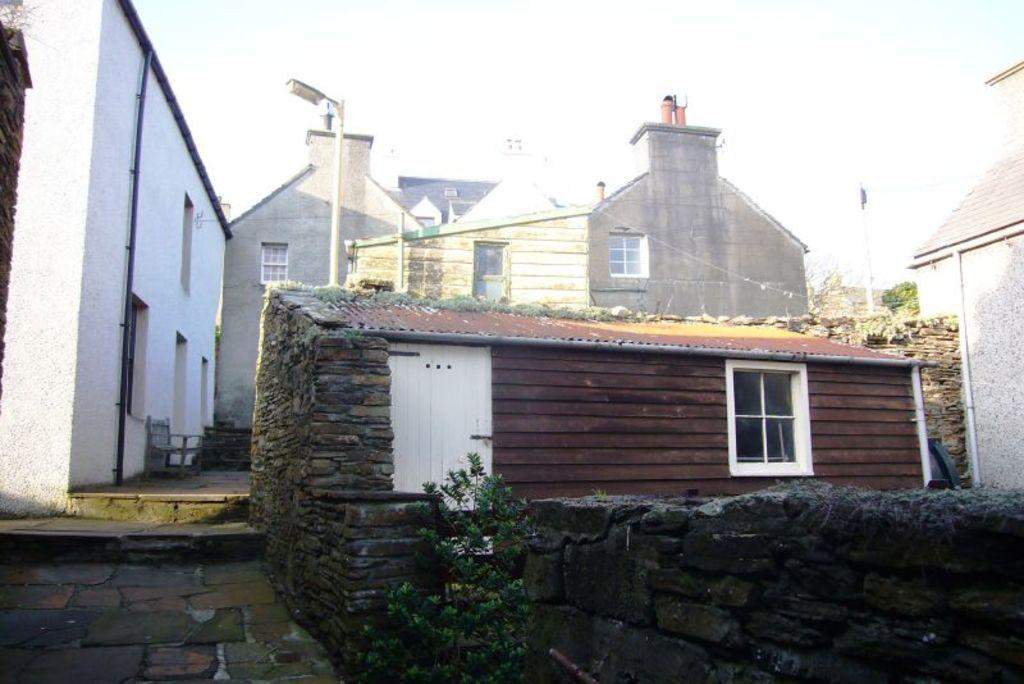What can be seen in the foreground of the picture? In the foreground of the picture, there are walls, a house, a door, and a window. What is located in the center of the picture? In the center of the picture, there are houses, a street light, a pole, and trees. Can you describe an object on the left side of the picture? On the left side of the picture, there is a chair. What country is the son from, who is flying the kite in the picture? There is no son or kite present in the picture, so it is not possible to answer that question. 